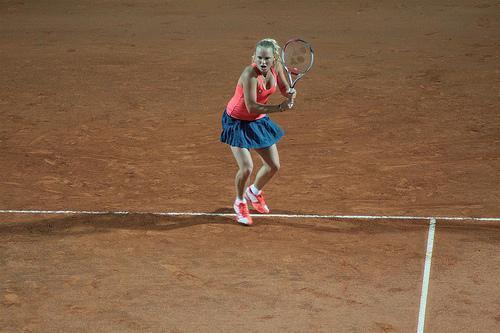How many people are in the picture?
Give a very brief answer. 1. 